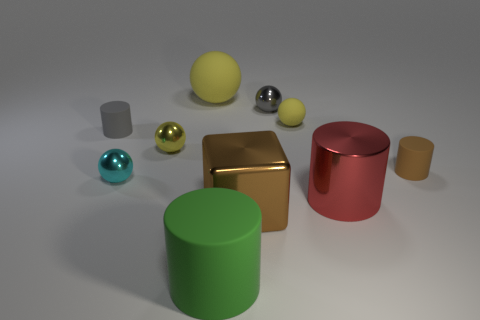There is a big metal cylinder on the right side of the small matte object that is behind the tiny gray matte cylinder; how many gray objects are left of it?
Ensure brevity in your answer.  2. There is a big thing that is in front of the big block; is it the same shape as the tiny yellow matte thing?
Provide a short and direct response. No. What number of things are small cyan metal balls or objects that are in front of the large yellow matte sphere?
Your answer should be very brief. 9. Is the number of big rubber spheres that are behind the gray matte cylinder greater than the number of large gray metal cylinders?
Give a very brief answer. Yes. Are there an equal number of things on the right side of the small gray metal ball and small yellow spheres to the right of the red metal cylinder?
Make the answer very short. No. Are there any balls in front of the small rubber thing that is to the right of the red shiny cylinder?
Offer a very short reply. Yes. The gray rubber thing is what shape?
Your response must be concise. Cylinder. What is the size of the metal sphere that is the same color as the small matte ball?
Make the answer very short. Small. What size is the yellow rubber thing that is on the left side of the big cylinder that is to the left of the small yellow matte object?
Keep it short and to the point. Large. What is the size of the green cylinder that is in front of the big rubber sphere?
Make the answer very short. Large. 